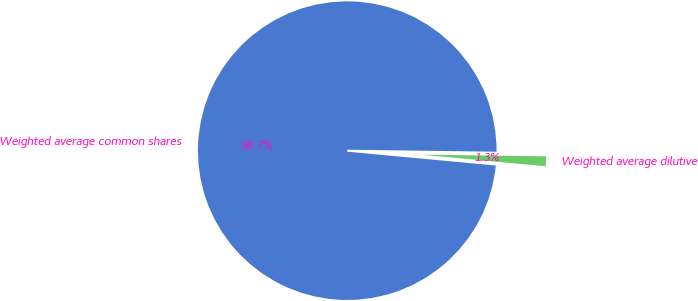Convert chart to OTSL. <chart><loc_0><loc_0><loc_500><loc_500><pie_chart><fcel>Weighted average common shares<fcel>Weighted average dilutive<nl><fcel>98.73%<fcel>1.27%<nl></chart> 